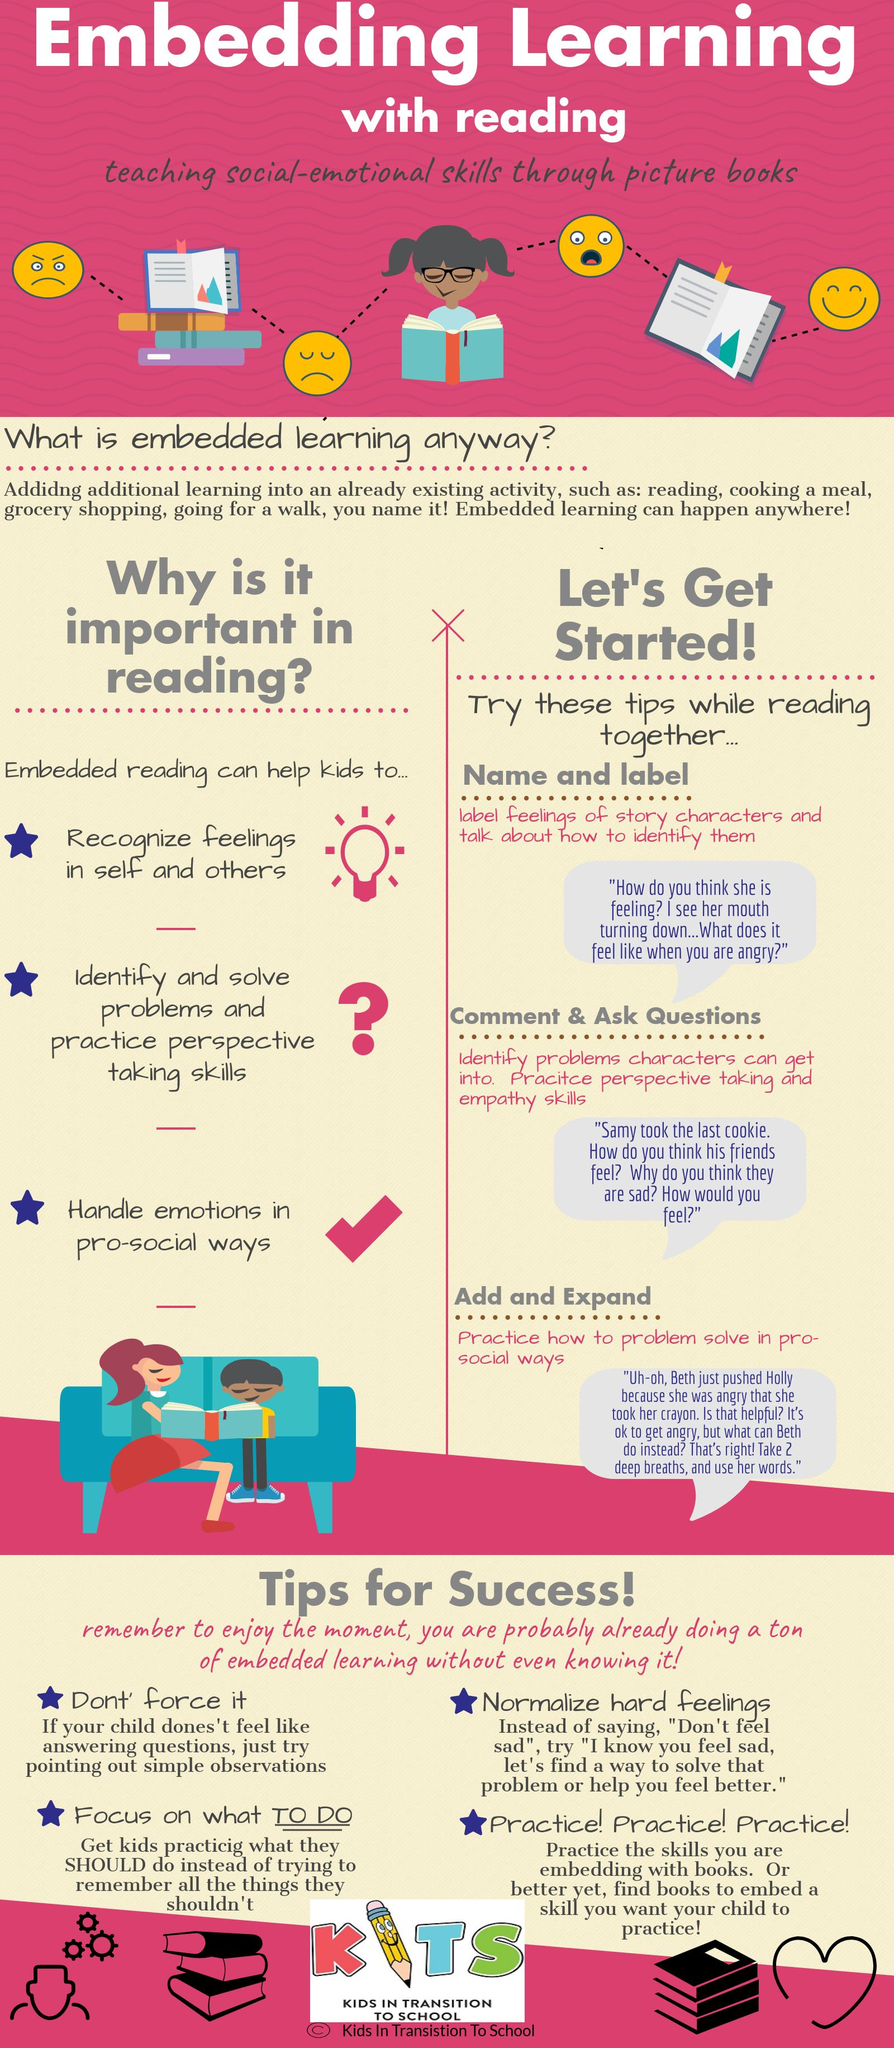Indicate a few pertinent items in this graphic. Embedded reading has been shown to benefit individuals by enabling them to handle emotions in a pro-social manner, which is listed as the third benefit. Embedded reading offers the benefit of identifying and solving problems and practicing perspective-taking skills, which is listed as the second advantage. Embedded reading is beneficial as it allows the recognition of feelings in oneself and others. 